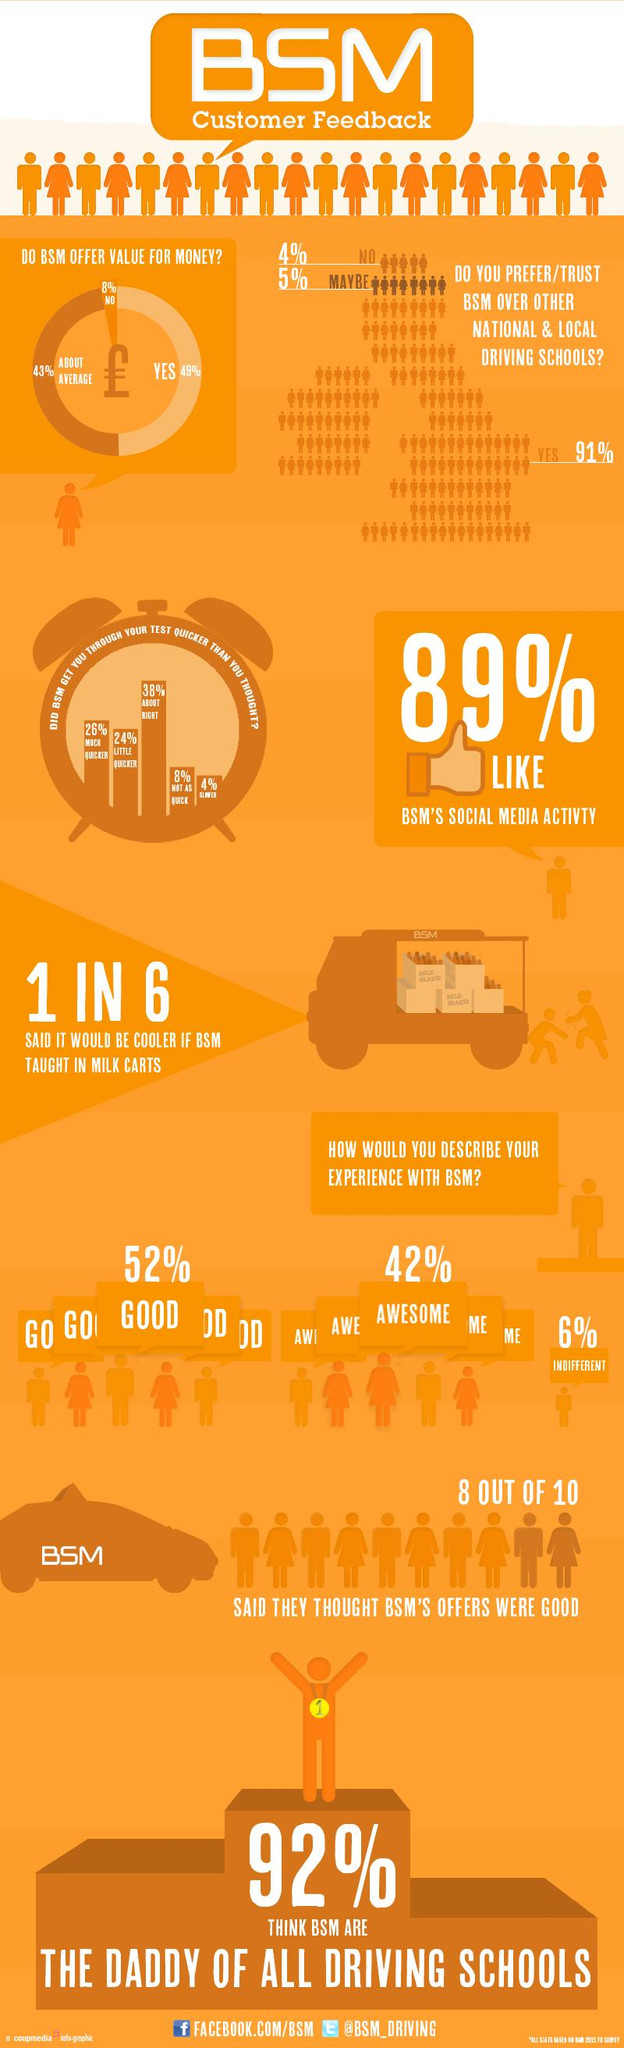Draw attention to some important aspects in this diagram. According to 50% of the people who thought that BSM helped them through the driving test, it made the process both little and much quicker. In a survey of people's experiences with Business Service Management, 52% described their experience as good, 42% described their experience as either good or very good, and 6% described their experience as either good or very good. 